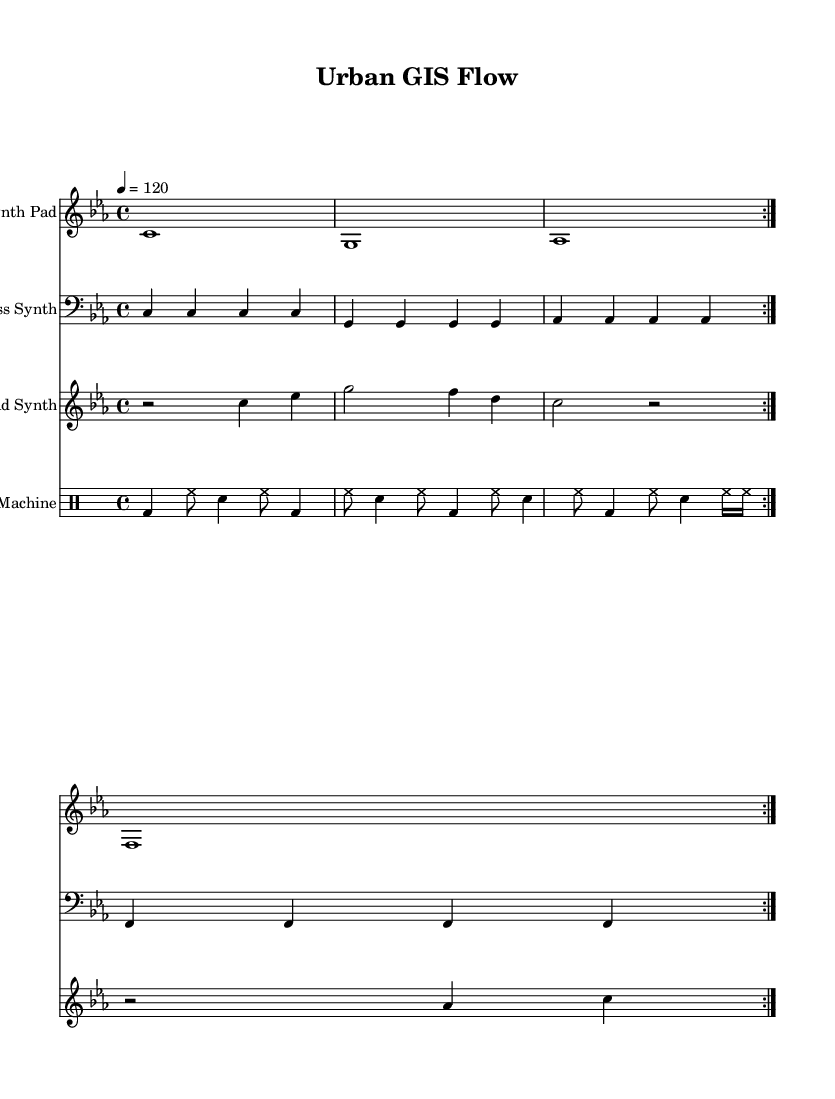What is the key signature of this music? The key signature is indicated by the placement of sharps or flats at the beginning of the staff. Here, there are three flats, indicating the key of C minor.
Answer: C minor What is the time signature of this music? The time signature is found at the start of the piece, displayed as a fraction. In this case, it shows 4 over 4, which means four beats per measure with a quarter note receiving one beat.
Answer: 4/4 What is the tempo marking for this piece? The tempo marking is specified above the staff and indicates the speed of the music. Here, it is written as "4 = 120," meaning that there are 120 beats per minute.
Answer: 120 How many measures are repeated in the Synth Pad section? The repetition is indicated by the "volta" markings, which signify that the music should repeat a specific number of times. The Synth Pad has a repeat indication of 4 measures.
Answer: 4 What is the function of the bass synth in this arrangement? The bass synth serves as a foundational element that typically provides harmonic support and rhythm. In this piece, it plays a repeated pattern creating a sense of stability and groove common in dance music.
Answer: Harmonic support How many different synthesized parts are present in this score? The score consists of four distinct parts: the Synth Pad, Bass Synth, Lead Synth, and Drum Machine. Each part adds a unique layer to the overall sound of the piece.
Answer: 4 What rhythm pattern does the drum machine follow? The rhythmic pattern of the drum machine is determined by the specific note values and their arrangement within the measures. The drum machine features alternating bass drum (bd), hi-hat (hh), and snare (sn) hits, providing a typical dance rhythm.
Answer: Alternating hits 